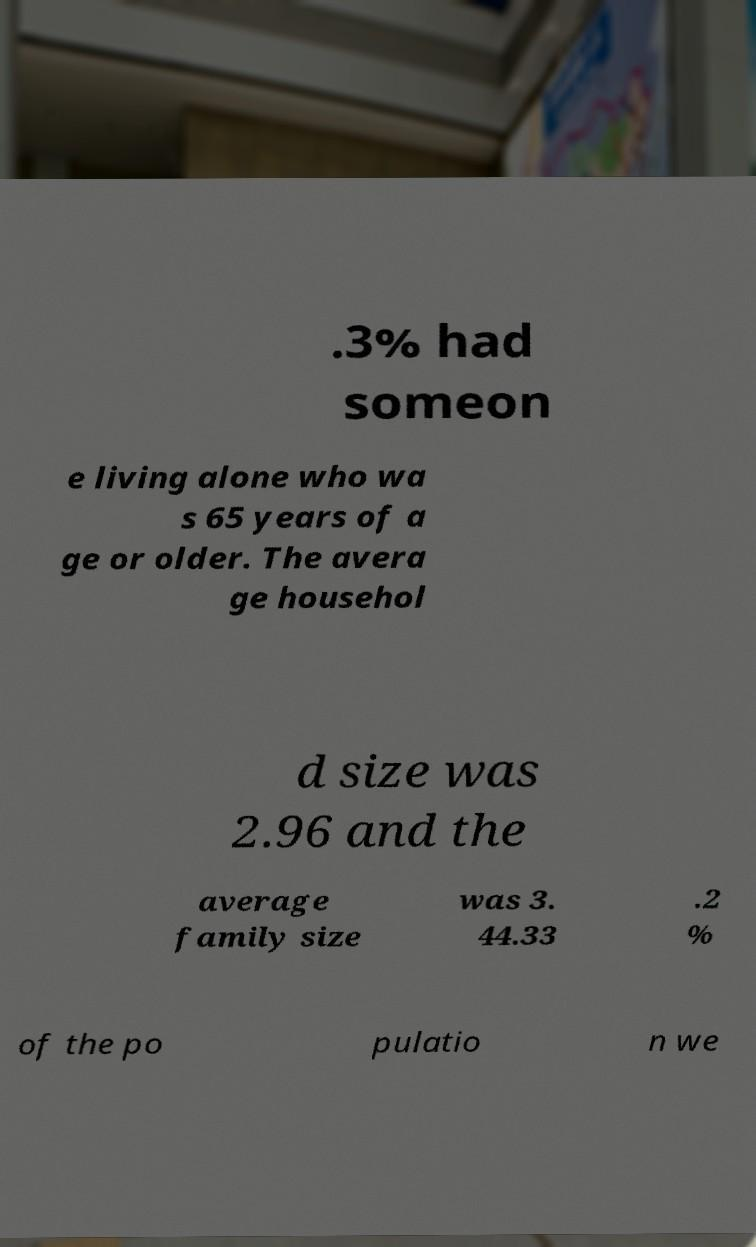Please read and relay the text visible in this image. What does it say? .3% had someon e living alone who wa s 65 years of a ge or older. The avera ge househol d size was 2.96 and the average family size was 3. 44.33 .2 % of the po pulatio n we 